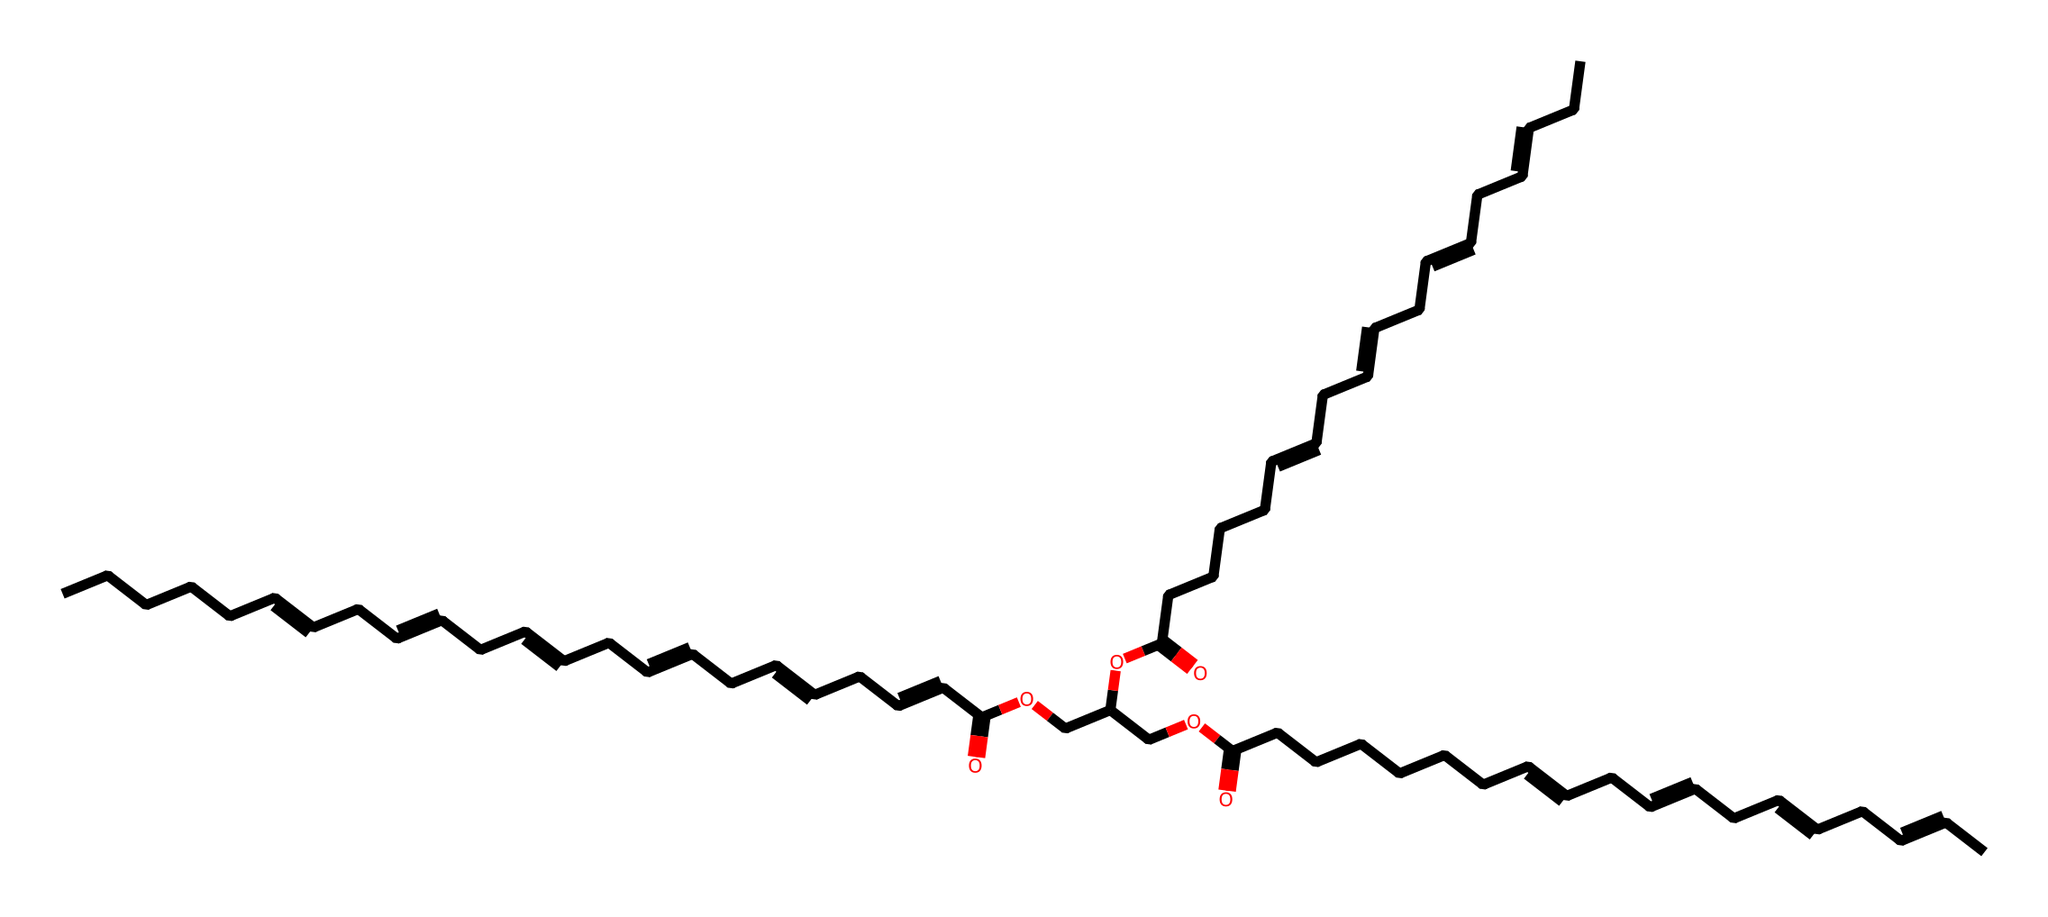What is the main functional group present in this chemical structure? Observing the structure, the presence of the carboxylic acid functional group (-COOH) is clear. This is identified by the carbon atom double-bonded to an oxygen and single-bonded to a hydroxyl group (–OH).
Answer: carboxylic acid How many carbon atoms are in this lipid structure? Counting the number of carbon (C) atoms throughout the provided SMILES representation indicates a total of 39 carbon atoms, which includes those in the fatty acid chains and the ester groups.
Answer: 39 What type of lipid is represented by this structure? Given the presence of long hydrocarbon chains and ester linkages, this structure classifies as a triglyceride. The presence of multiple fatty acids connected through glycerol confirms this classification.
Answer: triglyceride How many double bonds are present in this lipid structure? By inspecting the representation for the presence of double bonds (indicated by "=" symbols), it is determined that this structure contains six double bonds.
Answer: six What is the overall charge of this chemical? As the structure contains only neutral atoms in the functional groups and no ions, it indicates that there is no overall charge present in the molecule.
Answer: neutral Which part of this molecule primarily impacts its omega-3 fatty acid characteristics? The presence of multiple double bonds and the specific positioning in the carbon chain structure defines its omega-3 characteristics, specifically the location of the first double bond from the methyl end.
Answer: double bonds 